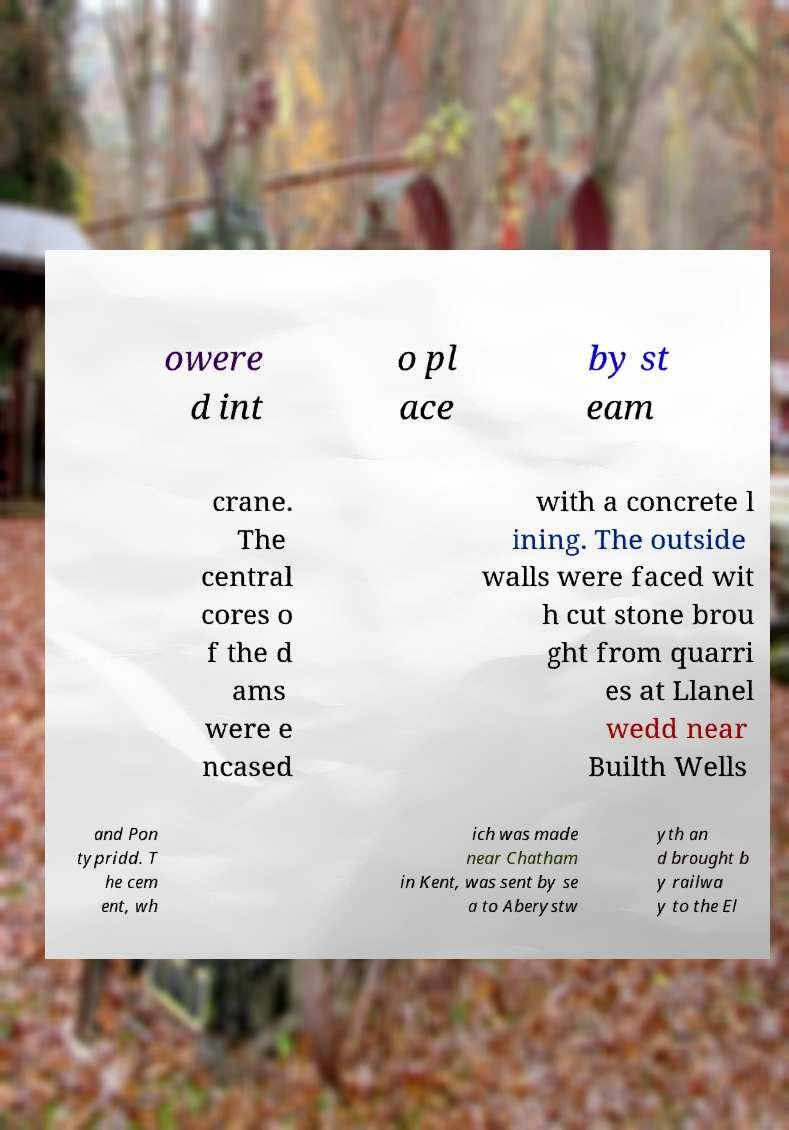Please identify and transcribe the text found in this image. owere d int o pl ace by st eam crane. The central cores o f the d ams were e ncased with a concrete l ining. The outside walls were faced wit h cut stone brou ght from quarri es at Llanel wedd near Builth Wells and Pon typridd. T he cem ent, wh ich was made near Chatham in Kent, was sent by se a to Aberystw yth an d brought b y railwa y to the El 